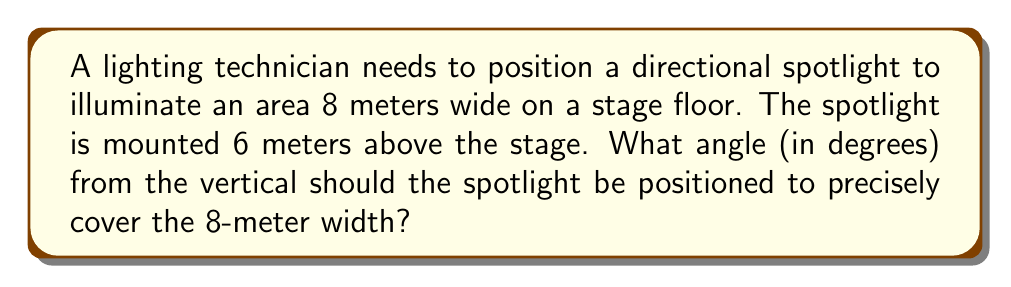Can you answer this question? Let's approach this step-by-step:

1) We can visualize this as a right triangle, where:
   - The vertical height is 6 meters
   - Half of the illuminated width is 4 meters (since the total width is 8 meters)
   - The angle we're looking for is between the vertical and the light beam

2) We can use the tangent function to find this angle. In a right triangle:

   $\tan(\theta) = \frac{\text{opposite}}{\text{adjacent}}$

3) In our case:
   - The opposite side is 4 meters (half the width)
   - The adjacent side is 6 meters (the height)

4) Let's call our angle $\theta$. We can write:

   $\tan(\theta) = \frac{4}{6}$

5) Simplify the fraction:

   $\tan(\theta) = \frac{2}{3}$

6) To find $\theta$, we need to use the inverse tangent (arctan or $\tan^{-1}$):

   $\theta = \tan^{-1}(\frac{2}{3})$

7) Using a calculator or computer:

   $\theta \approx 33.69$ degrees

8) Round to two decimal places:

   $\theta \approx 33.69$ degrees

This angle will allow the spotlight to precisely cover the 8-meter width on the stage floor.
Answer: $33.69°$ 